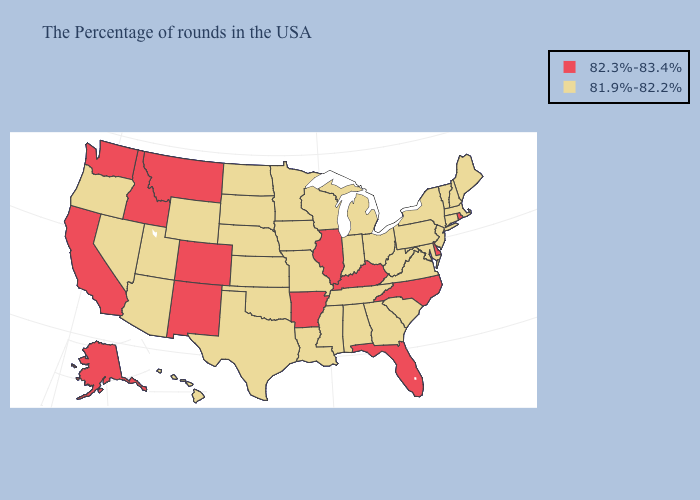Among the states that border California , which have the lowest value?
Answer briefly. Arizona, Nevada, Oregon. Name the states that have a value in the range 81.9%-82.2%?
Short answer required. Maine, Massachusetts, New Hampshire, Vermont, Connecticut, New York, New Jersey, Maryland, Pennsylvania, Virginia, South Carolina, West Virginia, Ohio, Georgia, Michigan, Indiana, Alabama, Tennessee, Wisconsin, Mississippi, Louisiana, Missouri, Minnesota, Iowa, Kansas, Nebraska, Oklahoma, Texas, South Dakota, North Dakota, Wyoming, Utah, Arizona, Nevada, Oregon, Hawaii. Does Hawaii have a higher value than Kentucky?
Write a very short answer. No. Name the states that have a value in the range 81.9%-82.2%?
Keep it brief. Maine, Massachusetts, New Hampshire, Vermont, Connecticut, New York, New Jersey, Maryland, Pennsylvania, Virginia, South Carolina, West Virginia, Ohio, Georgia, Michigan, Indiana, Alabama, Tennessee, Wisconsin, Mississippi, Louisiana, Missouri, Minnesota, Iowa, Kansas, Nebraska, Oklahoma, Texas, South Dakota, North Dakota, Wyoming, Utah, Arizona, Nevada, Oregon, Hawaii. Does Hawaii have the highest value in the West?
Concise answer only. No. How many symbols are there in the legend?
Be succinct. 2. Name the states that have a value in the range 82.3%-83.4%?
Keep it brief. Rhode Island, Delaware, North Carolina, Florida, Kentucky, Illinois, Arkansas, Colorado, New Mexico, Montana, Idaho, California, Washington, Alaska. What is the value of Massachusetts?
Keep it brief. 81.9%-82.2%. Name the states that have a value in the range 82.3%-83.4%?
Concise answer only. Rhode Island, Delaware, North Carolina, Florida, Kentucky, Illinois, Arkansas, Colorado, New Mexico, Montana, Idaho, California, Washington, Alaska. What is the lowest value in the West?
Short answer required. 81.9%-82.2%. Name the states that have a value in the range 81.9%-82.2%?
Give a very brief answer. Maine, Massachusetts, New Hampshire, Vermont, Connecticut, New York, New Jersey, Maryland, Pennsylvania, Virginia, South Carolina, West Virginia, Ohio, Georgia, Michigan, Indiana, Alabama, Tennessee, Wisconsin, Mississippi, Louisiana, Missouri, Minnesota, Iowa, Kansas, Nebraska, Oklahoma, Texas, South Dakota, North Dakota, Wyoming, Utah, Arizona, Nevada, Oregon, Hawaii. What is the value of Iowa?
Short answer required. 81.9%-82.2%. Does Hawaii have the highest value in the West?
Short answer required. No. Name the states that have a value in the range 82.3%-83.4%?
Keep it brief. Rhode Island, Delaware, North Carolina, Florida, Kentucky, Illinois, Arkansas, Colorado, New Mexico, Montana, Idaho, California, Washington, Alaska. 